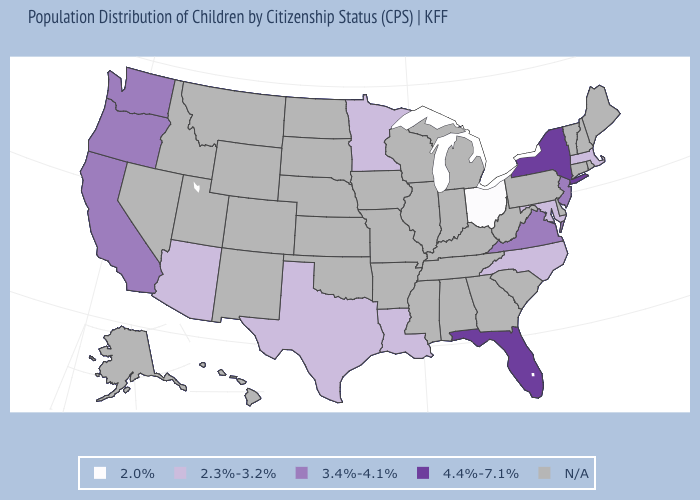Name the states that have a value in the range 2.0%?
Concise answer only. Ohio. Is the legend a continuous bar?
Concise answer only. No. Among the states that border New Mexico , which have the lowest value?
Quick response, please. Arizona, Texas. What is the highest value in the West ?
Be succinct. 3.4%-4.1%. Name the states that have a value in the range 2.0%?
Short answer required. Ohio. Does California have the highest value in the West?
Answer briefly. Yes. What is the value of Indiana?
Write a very short answer. N/A. What is the highest value in the USA?
Keep it brief. 4.4%-7.1%. How many symbols are there in the legend?
Write a very short answer. 5. Name the states that have a value in the range 4.4%-7.1%?
Be succinct. Florida, New York. Name the states that have a value in the range 2.0%?
Answer briefly. Ohio. Name the states that have a value in the range 2.3%-3.2%?
Write a very short answer. Arizona, Louisiana, Maryland, Massachusetts, Minnesota, North Carolina, Texas. 